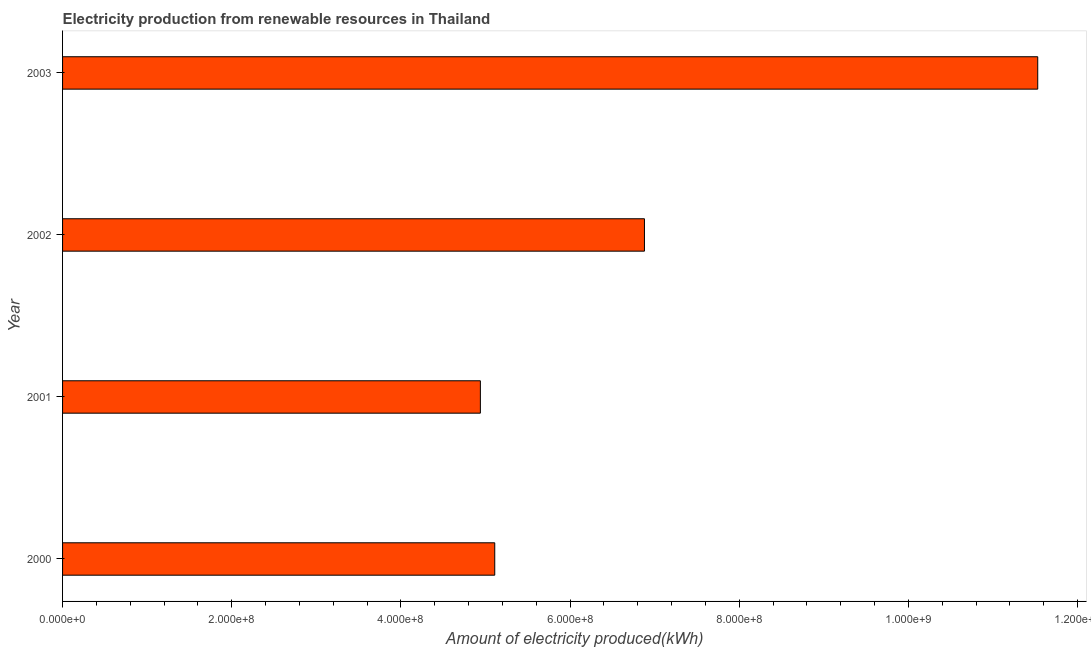Does the graph contain any zero values?
Your answer should be very brief. No. What is the title of the graph?
Ensure brevity in your answer.  Electricity production from renewable resources in Thailand. What is the label or title of the X-axis?
Provide a short and direct response. Amount of electricity produced(kWh). What is the amount of electricity produced in 2000?
Make the answer very short. 5.11e+08. Across all years, what is the maximum amount of electricity produced?
Keep it short and to the point. 1.15e+09. Across all years, what is the minimum amount of electricity produced?
Provide a succinct answer. 4.94e+08. In which year was the amount of electricity produced maximum?
Give a very brief answer. 2003. What is the sum of the amount of electricity produced?
Provide a succinct answer. 2.85e+09. What is the difference between the amount of electricity produced in 2000 and 2002?
Offer a very short reply. -1.77e+08. What is the average amount of electricity produced per year?
Provide a succinct answer. 7.12e+08. What is the median amount of electricity produced?
Ensure brevity in your answer.  6.00e+08. In how many years, is the amount of electricity produced greater than 160000000 kWh?
Keep it short and to the point. 4. What is the ratio of the amount of electricity produced in 2000 to that in 2003?
Make the answer very short. 0.44. Is the amount of electricity produced in 2001 less than that in 2002?
Offer a very short reply. Yes. What is the difference between the highest and the second highest amount of electricity produced?
Your response must be concise. 4.65e+08. What is the difference between the highest and the lowest amount of electricity produced?
Ensure brevity in your answer.  6.59e+08. How many years are there in the graph?
Your answer should be very brief. 4. What is the Amount of electricity produced(kWh) of 2000?
Your answer should be compact. 5.11e+08. What is the Amount of electricity produced(kWh) of 2001?
Offer a very short reply. 4.94e+08. What is the Amount of electricity produced(kWh) of 2002?
Your answer should be very brief. 6.88e+08. What is the Amount of electricity produced(kWh) in 2003?
Your answer should be compact. 1.15e+09. What is the difference between the Amount of electricity produced(kWh) in 2000 and 2001?
Your response must be concise. 1.70e+07. What is the difference between the Amount of electricity produced(kWh) in 2000 and 2002?
Your answer should be compact. -1.77e+08. What is the difference between the Amount of electricity produced(kWh) in 2000 and 2003?
Provide a succinct answer. -6.42e+08. What is the difference between the Amount of electricity produced(kWh) in 2001 and 2002?
Your answer should be very brief. -1.94e+08. What is the difference between the Amount of electricity produced(kWh) in 2001 and 2003?
Ensure brevity in your answer.  -6.59e+08. What is the difference between the Amount of electricity produced(kWh) in 2002 and 2003?
Ensure brevity in your answer.  -4.65e+08. What is the ratio of the Amount of electricity produced(kWh) in 2000 to that in 2001?
Offer a terse response. 1.03. What is the ratio of the Amount of electricity produced(kWh) in 2000 to that in 2002?
Your response must be concise. 0.74. What is the ratio of the Amount of electricity produced(kWh) in 2000 to that in 2003?
Your response must be concise. 0.44. What is the ratio of the Amount of electricity produced(kWh) in 2001 to that in 2002?
Make the answer very short. 0.72. What is the ratio of the Amount of electricity produced(kWh) in 2001 to that in 2003?
Provide a succinct answer. 0.43. What is the ratio of the Amount of electricity produced(kWh) in 2002 to that in 2003?
Ensure brevity in your answer.  0.6. 